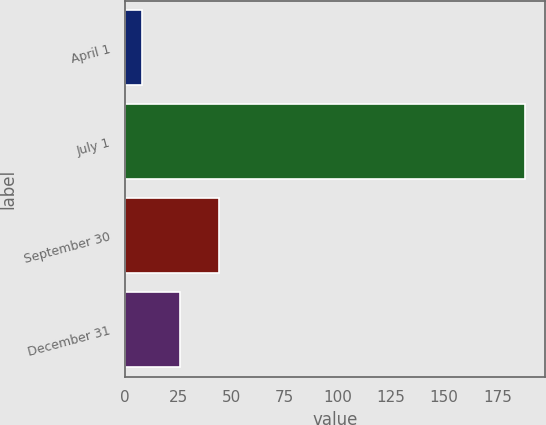<chart> <loc_0><loc_0><loc_500><loc_500><bar_chart><fcel>April 1<fcel>July 1<fcel>September 30<fcel>December 31<nl><fcel>8<fcel>188<fcel>44<fcel>26<nl></chart> 